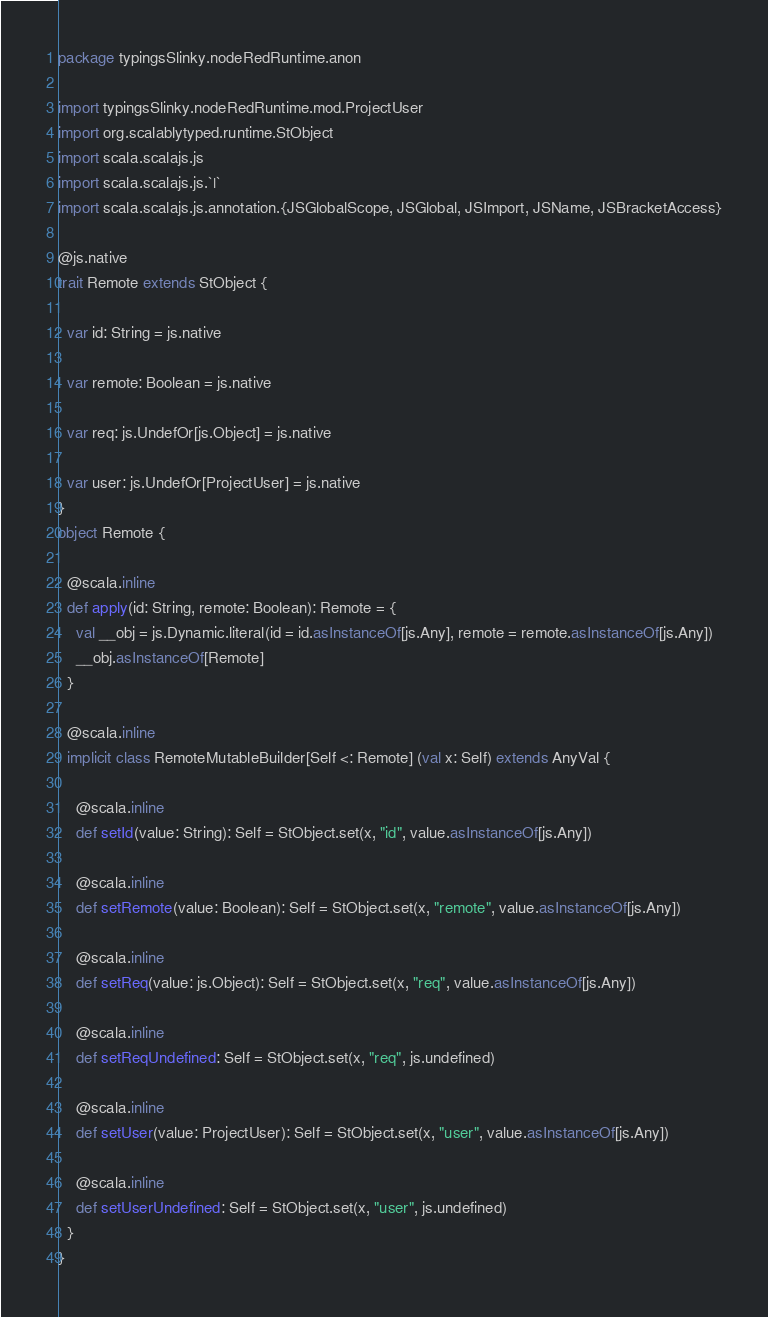<code> <loc_0><loc_0><loc_500><loc_500><_Scala_>package typingsSlinky.nodeRedRuntime.anon

import typingsSlinky.nodeRedRuntime.mod.ProjectUser
import org.scalablytyped.runtime.StObject
import scala.scalajs.js
import scala.scalajs.js.`|`
import scala.scalajs.js.annotation.{JSGlobalScope, JSGlobal, JSImport, JSName, JSBracketAccess}

@js.native
trait Remote extends StObject {
  
  var id: String = js.native
  
  var remote: Boolean = js.native
  
  var req: js.UndefOr[js.Object] = js.native
  
  var user: js.UndefOr[ProjectUser] = js.native
}
object Remote {
  
  @scala.inline
  def apply(id: String, remote: Boolean): Remote = {
    val __obj = js.Dynamic.literal(id = id.asInstanceOf[js.Any], remote = remote.asInstanceOf[js.Any])
    __obj.asInstanceOf[Remote]
  }
  
  @scala.inline
  implicit class RemoteMutableBuilder[Self <: Remote] (val x: Self) extends AnyVal {
    
    @scala.inline
    def setId(value: String): Self = StObject.set(x, "id", value.asInstanceOf[js.Any])
    
    @scala.inline
    def setRemote(value: Boolean): Self = StObject.set(x, "remote", value.asInstanceOf[js.Any])
    
    @scala.inline
    def setReq(value: js.Object): Self = StObject.set(x, "req", value.asInstanceOf[js.Any])
    
    @scala.inline
    def setReqUndefined: Self = StObject.set(x, "req", js.undefined)
    
    @scala.inline
    def setUser(value: ProjectUser): Self = StObject.set(x, "user", value.asInstanceOf[js.Any])
    
    @scala.inline
    def setUserUndefined: Self = StObject.set(x, "user", js.undefined)
  }
}
</code> 